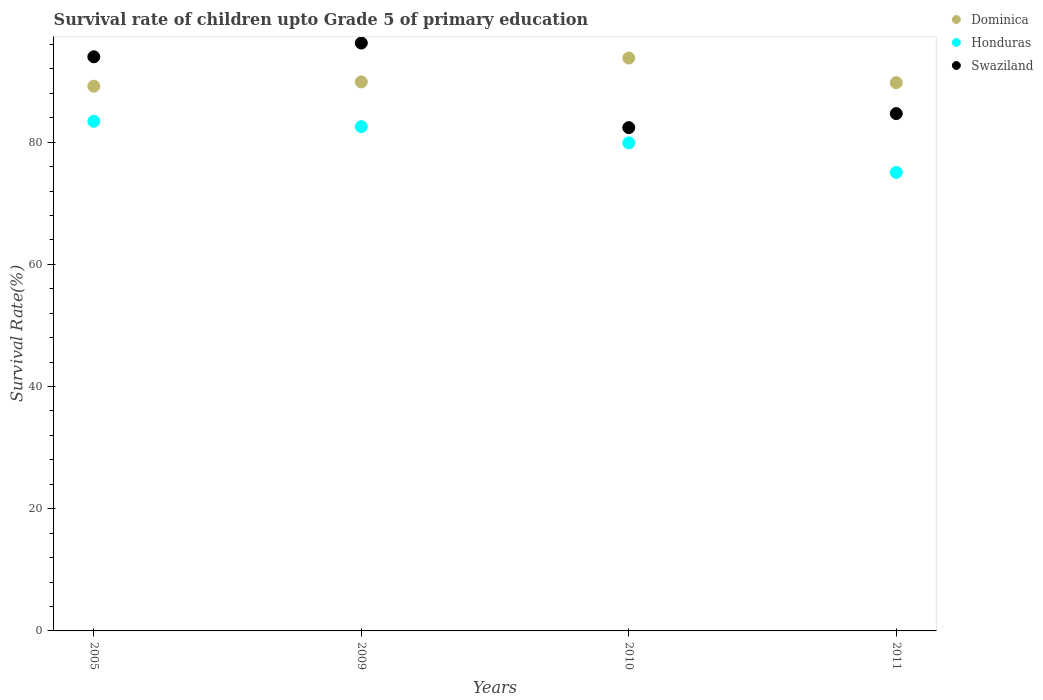How many different coloured dotlines are there?
Ensure brevity in your answer.  3. Is the number of dotlines equal to the number of legend labels?
Provide a succinct answer. Yes. What is the survival rate of children in Swaziland in 2010?
Offer a terse response. 82.38. Across all years, what is the maximum survival rate of children in Honduras?
Ensure brevity in your answer.  83.42. Across all years, what is the minimum survival rate of children in Honduras?
Ensure brevity in your answer.  75.05. In which year was the survival rate of children in Swaziland maximum?
Offer a terse response. 2009. In which year was the survival rate of children in Swaziland minimum?
Ensure brevity in your answer.  2010. What is the total survival rate of children in Honduras in the graph?
Your response must be concise. 320.89. What is the difference between the survival rate of children in Dominica in 2009 and that in 2010?
Keep it short and to the point. -3.9. What is the difference between the survival rate of children in Dominica in 2011 and the survival rate of children in Swaziland in 2009?
Offer a terse response. -6.49. What is the average survival rate of children in Swaziland per year?
Your answer should be very brief. 89.31. In the year 2005, what is the difference between the survival rate of children in Dominica and survival rate of children in Swaziland?
Offer a terse response. -4.81. In how many years, is the survival rate of children in Dominica greater than 28 %?
Make the answer very short. 4. What is the ratio of the survival rate of children in Dominica in 2005 to that in 2010?
Your response must be concise. 0.95. Is the survival rate of children in Swaziland in 2005 less than that in 2010?
Make the answer very short. No. What is the difference between the highest and the second highest survival rate of children in Swaziland?
Offer a very short reply. 2.25. What is the difference between the highest and the lowest survival rate of children in Honduras?
Offer a terse response. 8.37. Is the survival rate of children in Swaziland strictly greater than the survival rate of children in Honduras over the years?
Your response must be concise. Yes. Is the survival rate of children in Swaziland strictly less than the survival rate of children in Dominica over the years?
Ensure brevity in your answer.  No. How many years are there in the graph?
Your answer should be compact. 4. What is the difference between two consecutive major ticks on the Y-axis?
Provide a short and direct response. 20. Does the graph contain any zero values?
Make the answer very short. No. Does the graph contain grids?
Make the answer very short. No. What is the title of the graph?
Provide a succinct answer. Survival rate of children upto Grade 5 of primary education. Does "Heavily indebted poor countries" appear as one of the legend labels in the graph?
Your response must be concise. No. What is the label or title of the X-axis?
Offer a very short reply. Years. What is the label or title of the Y-axis?
Offer a terse response. Survival Rate(%). What is the Survival Rate(%) in Dominica in 2005?
Offer a terse response. 89.17. What is the Survival Rate(%) in Honduras in 2005?
Your answer should be compact. 83.42. What is the Survival Rate(%) of Swaziland in 2005?
Keep it short and to the point. 93.97. What is the Survival Rate(%) of Dominica in 2009?
Provide a succinct answer. 89.87. What is the Survival Rate(%) in Honduras in 2009?
Your response must be concise. 82.54. What is the Survival Rate(%) in Swaziland in 2009?
Give a very brief answer. 96.23. What is the Survival Rate(%) of Dominica in 2010?
Provide a succinct answer. 93.77. What is the Survival Rate(%) in Honduras in 2010?
Ensure brevity in your answer.  79.88. What is the Survival Rate(%) of Swaziland in 2010?
Offer a very short reply. 82.38. What is the Survival Rate(%) in Dominica in 2011?
Keep it short and to the point. 89.74. What is the Survival Rate(%) of Honduras in 2011?
Ensure brevity in your answer.  75.05. What is the Survival Rate(%) in Swaziland in 2011?
Provide a succinct answer. 84.68. Across all years, what is the maximum Survival Rate(%) of Dominica?
Your answer should be very brief. 93.77. Across all years, what is the maximum Survival Rate(%) of Honduras?
Your answer should be very brief. 83.42. Across all years, what is the maximum Survival Rate(%) of Swaziland?
Your response must be concise. 96.23. Across all years, what is the minimum Survival Rate(%) in Dominica?
Keep it short and to the point. 89.17. Across all years, what is the minimum Survival Rate(%) of Honduras?
Keep it short and to the point. 75.05. Across all years, what is the minimum Survival Rate(%) of Swaziland?
Offer a very short reply. 82.38. What is the total Survival Rate(%) of Dominica in the graph?
Provide a short and direct response. 362.54. What is the total Survival Rate(%) in Honduras in the graph?
Make the answer very short. 320.89. What is the total Survival Rate(%) in Swaziland in the graph?
Keep it short and to the point. 357.26. What is the difference between the Survival Rate(%) of Dominica in 2005 and that in 2009?
Give a very brief answer. -0.7. What is the difference between the Survival Rate(%) in Honduras in 2005 and that in 2009?
Make the answer very short. 0.88. What is the difference between the Survival Rate(%) in Swaziland in 2005 and that in 2009?
Offer a terse response. -2.25. What is the difference between the Survival Rate(%) of Dominica in 2005 and that in 2010?
Offer a very short reply. -4.6. What is the difference between the Survival Rate(%) of Honduras in 2005 and that in 2010?
Give a very brief answer. 3.53. What is the difference between the Survival Rate(%) in Swaziland in 2005 and that in 2010?
Give a very brief answer. 11.59. What is the difference between the Survival Rate(%) of Dominica in 2005 and that in 2011?
Offer a very short reply. -0.57. What is the difference between the Survival Rate(%) of Honduras in 2005 and that in 2011?
Your response must be concise. 8.37. What is the difference between the Survival Rate(%) of Swaziland in 2005 and that in 2011?
Your answer should be compact. 9.3. What is the difference between the Survival Rate(%) of Dominica in 2009 and that in 2010?
Your response must be concise. -3.9. What is the difference between the Survival Rate(%) in Honduras in 2009 and that in 2010?
Give a very brief answer. 2.65. What is the difference between the Survival Rate(%) of Swaziland in 2009 and that in 2010?
Ensure brevity in your answer.  13.84. What is the difference between the Survival Rate(%) of Dominica in 2009 and that in 2011?
Your answer should be compact. 0.13. What is the difference between the Survival Rate(%) in Honduras in 2009 and that in 2011?
Provide a succinct answer. 7.49. What is the difference between the Survival Rate(%) of Swaziland in 2009 and that in 2011?
Your answer should be very brief. 11.55. What is the difference between the Survival Rate(%) in Dominica in 2010 and that in 2011?
Your answer should be very brief. 4.03. What is the difference between the Survival Rate(%) of Honduras in 2010 and that in 2011?
Your answer should be very brief. 4.83. What is the difference between the Survival Rate(%) in Swaziland in 2010 and that in 2011?
Give a very brief answer. -2.29. What is the difference between the Survival Rate(%) in Dominica in 2005 and the Survival Rate(%) in Honduras in 2009?
Offer a terse response. 6.63. What is the difference between the Survival Rate(%) in Dominica in 2005 and the Survival Rate(%) in Swaziland in 2009?
Your answer should be very brief. -7.06. What is the difference between the Survival Rate(%) in Honduras in 2005 and the Survival Rate(%) in Swaziland in 2009?
Offer a terse response. -12.81. What is the difference between the Survival Rate(%) of Dominica in 2005 and the Survival Rate(%) of Honduras in 2010?
Make the answer very short. 9.28. What is the difference between the Survival Rate(%) in Dominica in 2005 and the Survival Rate(%) in Swaziland in 2010?
Offer a very short reply. 6.78. What is the difference between the Survival Rate(%) of Honduras in 2005 and the Survival Rate(%) of Swaziland in 2010?
Ensure brevity in your answer.  1.03. What is the difference between the Survival Rate(%) in Dominica in 2005 and the Survival Rate(%) in Honduras in 2011?
Your response must be concise. 14.12. What is the difference between the Survival Rate(%) of Dominica in 2005 and the Survival Rate(%) of Swaziland in 2011?
Your response must be concise. 4.49. What is the difference between the Survival Rate(%) of Honduras in 2005 and the Survival Rate(%) of Swaziland in 2011?
Your response must be concise. -1.26. What is the difference between the Survival Rate(%) of Dominica in 2009 and the Survival Rate(%) of Honduras in 2010?
Keep it short and to the point. 9.98. What is the difference between the Survival Rate(%) of Dominica in 2009 and the Survival Rate(%) of Swaziland in 2010?
Offer a terse response. 7.48. What is the difference between the Survival Rate(%) in Honduras in 2009 and the Survival Rate(%) in Swaziland in 2010?
Provide a short and direct response. 0.15. What is the difference between the Survival Rate(%) in Dominica in 2009 and the Survival Rate(%) in Honduras in 2011?
Ensure brevity in your answer.  14.82. What is the difference between the Survival Rate(%) in Dominica in 2009 and the Survival Rate(%) in Swaziland in 2011?
Your response must be concise. 5.19. What is the difference between the Survival Rate(%) in Honduras in 2009 and the Survival Rate(%) in Swaziland in 2011?
Your response must be concise. -2.14. What is the difference between the Survival Rate(%) in Dominica in 2010 and the Survival Rate(%) in Honduras in 2011?
Offer a terse response. 18.72. What is the difference between the Survival Rate(%) of Dominica in 2010 and the Survival Rate(%) of Swaziland in 2011?
Provide a short and direct response. 9.09. What is the difference between the Survival Rate(%) of Honduras in 2010 and the Survival Rate(%) of Swaziland in 2011?
Your response must be concise. -4.79. What is the average Survival Rate(%) in Dominica per year?
Your answer should be compact. 90.63. What is the average Survival Rate(%) of Honduras per year?
Offer a very short reply. 80.22. What is the average Survival Rate(%) of Swaziland per year?
Give a very brief answer. 89.31. In the year 2005, what is the difference between the Survival Rate(%) in Dominica and Survival Rate(%) in Honduras?
Your answer should be very brief. 5.75. In the year 2005, what is the difference between the Survival Rate(%) in Dominica and Survival Rate(%) in Swaziland?
Your response must be concise. -4.81. In the year 2005, what is the difference between the Survival Rate(%) in Honduras and Survival Rate(%) in Swaziland?
Your response must be concise. -10.55. In the year 2009, what is the difference between the Survival Rate(%) of Dominica and Survival Rate(%) of Honduras?
Your response must be concise. 7.33. In the year 2009, what is the difference between the Survival Rate(%) of Dominica and Survival Rate(%) of Swaziland?
Provide a succinct answer. -6.36. In the year 2009, what is the difference between the Survival Rate(%) in Honduras and Survival Rate(%) in Swaziland?
Give a very brief answer. -13.69. In the year 2010, what is the difference between the Survival Rate(%) in Dominica and Survival Rate(%) in Honduras?
Provide a succinct answer. 13.88. In the year 2010, what is the difference between the Survival Rate(%) of Dominica and Survival Rate(%) of Swaziland?
Offer a very short reply. 11.38. In the year 2010, what is the difference between the Survival Rate(%) of Honduras and Survival Rate(%) of Swaziland?
Provide a short and direct response. -2.5. In the year 2011, what is the difference between the Survival Rate(%) in Dominica and Survival Rate(%) in Honduras?
Offer a very short reply. 14.69. In the year 2011, what is the difference between the Survival Rate(%) in Dominica and Survival Rate(%) in Swaziland?
Provide a short and direct response. 5.06. In the year 2011, what is the difference between the Survival Rate(%) of Honduras and Survival Rate(%) of Swaziland?
Ensure brevity in your answer.  -9.63. What is the ratio of the Survival Rate(%) of Honduras in 2005 to that in 2009?
Your response must be concise. 1.01. What is the ratio of the Survival Rate(%) of Swaziland in 2005 to that in 2009?
Provide a succinct answer. 0.98. What is the ratio of the Survival Rate(%) of Dominica in 2005 to that in 2010?
Your answer should be compact. 0.95. What is the ratio of the Survival Rate(%) in Honduras in 2005 to that in 2010?
Your answer should be compact. 1.04. What is the ratio of the Survival Rate(%) in Swaziland in 2005 to that in 2010?
Provide a short and direct response. 1.14. What is the ratio of the Survival Rate(%) in Dominica in 2005 to that in 2011?
Keep it short and to the point. 0.99. What is the ratio of the Survival Rate(%) of Honduras in 2005 to that in 2011?
Provide a short and direct response. 1.11. What is the ratio of the Survival Rate(%) of Swaziland in 2005 to that in 2011?
Your answer should be very brief. 1.11. What is the ratio of the Survival Rate(%) of Dominica in 2009 to that in 2010?
Provide a succinct answer. 0.96. What is the ratio of the Survival Rate(%) in Honduras in 2009 to that in 2010?
Ensure brevity in your answer.  1.03. What is the ratio of the Survival Rate(%) in Swaziland in 2009 to that in 2010?
Your response must be concise. 1.17. What is the ratio of the Survival Rate(%) of Dominica in 2009 to that in 2011?
Your answer should be compact. 1. What is the ratio of the Survival Rate(%) of Honduras in 2009 to that in 2011?
Offer a very short reply. 1.1. What is the ratio of the Survival Rate(%) of Swaziland in 2009 to that in 2011?
Provide a succinct answer. 1.14. What is the ratio of the Survival Rate(%) in Dominica in 2010 to that in 2011?
Provide a short and direct response. 1.04. What is the ratio of the Survival Rate(%) of Honduras in 2010 to that in 2011?
Offer a terse response. 1.06. What is the ratio of the Survival Rate(%) of Swaziland in 2010 to that in 2011?
Offer a terse response. 0.97. What is the difference between the highest and the second highest Survival Rate(%) in Dominica?
Offer a very short reply. 3.9. What is the difference between the highest and the second highest Survival Rate(%) in Honduras?
Provide a short and direct response. 0.88. What is the difference between the highest and the second highest Survival Rate(%) of Swaziland?
Your answer should be compact. 2.25. What is the difference between the highest and the lowest Survival Rate(%) in Dominica?
Your answer should be compact. 4.6. What is the difference between the highest and the lowest Survival Rate(%) in Honduras?
Your answer should be very brief. 8.37. What is the difference between the highest and the lowest Survival Rate(%) of Swaziland?
Offer a very short reply. 13.84. 